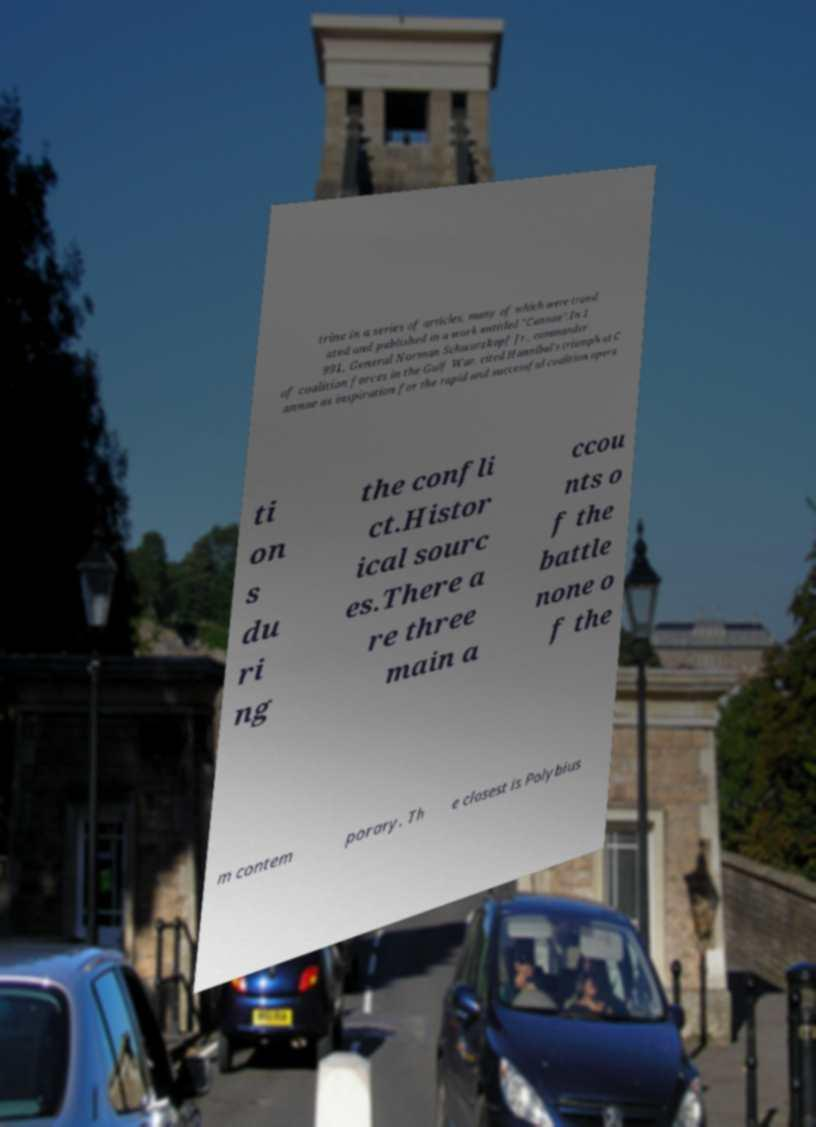Please read and relay the text visible in this image. What does it say? trine in a series of articles, many of which were transl ated and published in a work entitled "Cannae".In 1 991, General Norman Schwarzkopf Jr., commander of coalition forces in the Gulf War, cited Hannibal's triumph at C annae as inspiration for the rapid and successful coalition opera ti on s du ri ng the confli ct.Histor ical sourc es.There a re three main a ccou nts o f the battle none o f the m contem porary. Th e closest is Polybius 